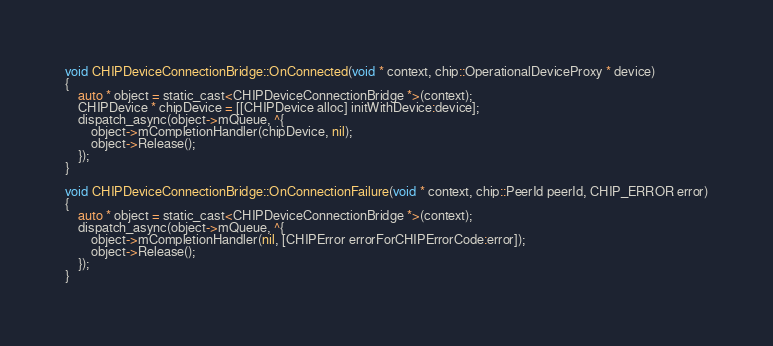<code> <loc_0><loc_0><loc_500><loc_500><_ObjectiveC_>
void CHIPDeviceConnectionBridge::OnConnected(void * context, chip::OperationalDeviceProxy * device)
{
    auto * object = static_cast<CHIPDeviceConnectionBridge *>(context);
    CHIPDevice * chipDevice = [[CHIPDevice alloc] initWithDevice:device];
    dispatch_async(object->mQueue, ^{
        object->mCompletionHandler(chipDevice, nil);
        object->Release();
    });
}

void CHIPDeviceConnectionBridge::OnConnectionFailure(void * context, chip::PeerId peerId, CHIP_ERROR error)
{
    auto * object = static_cast<CHIPDeviceConnectionBridge *>(context);
    dispatch_async(object->mQueue, ^{
        object->mCompletionHandler(nil, [CHIPError errorForCHIPErrorCode:error]);
        object->Release();
    });
}
</code> 